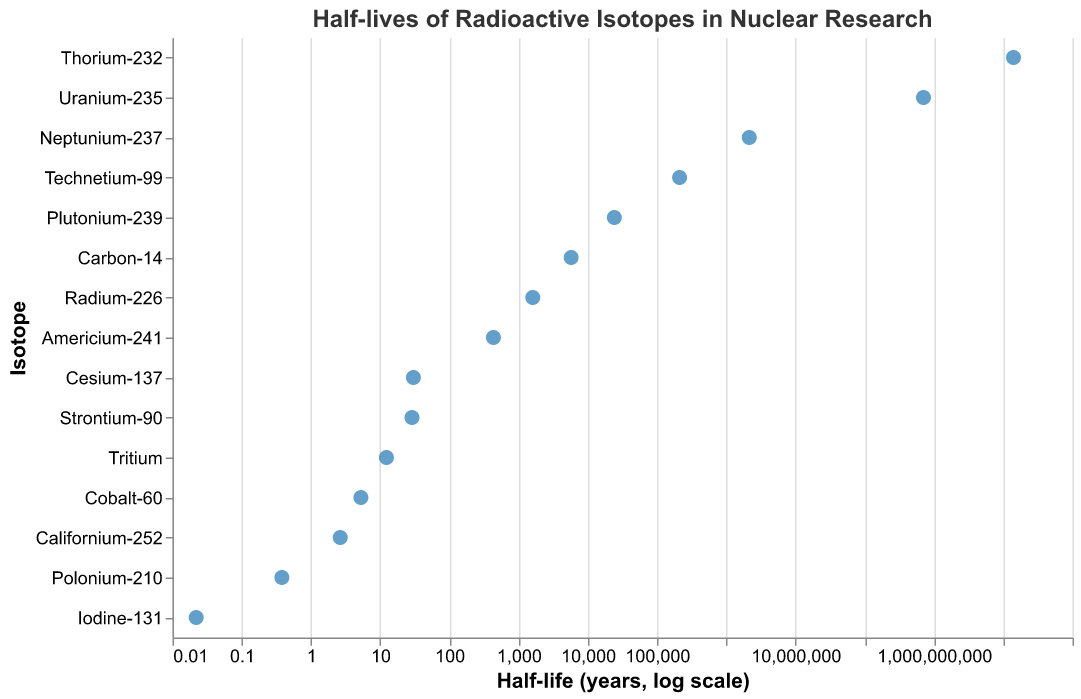What is the title of the plot? The title of the plot is written at the top of the figure for easy identification.
Answer: Half-lives of Radioactive Isotopes in Nuclear Research How many isotopes are represented in the plot? Each isotope is listed on the y-axis, and by counting them, we can determine the number of isotopes. There are 15 isotopes listed.
Answer: 15 Which isotope has the longest half-life? The isotope with the longest half-life will be at the top of the y-axis when sorted in descending order of half-life. Thorium-232 has the longest half-life.
Answer: Thorium-232 Which isotope has the shortest half-life? The isotope with the shortest half-life will be at the bottom of the y-axis when sorted in descending order of half-life. Iodine-131 has the shortest half-life.
Answer: Iodine-131 What is the half-life of Carbon-14? The tooltip or the position on the x-axis corresponding to Carbon-14 will give the half-life. It's labeled on the plot.
Answer: 5730 years Compare the half-lives of Uranium-235 and Plutonium-239. Which one has a longer half-life and by how much? From the plot, identify the half-lives of Uranium-235 and Plutonium-239. Uranium-235's half-life is 703,800,000 years, while Plutonium-239's half-life is 24,100 years. The difference is calculated by subtraction.
Answer: Uranium-235 by 703,775,900 years What is the average half-life of Tritium and Californium-252? Identify the half-lives of Tritium (12.32 years) and Californium-252 (2.65 years) from the plot. Add them together and divide by 2 to get the average. (12.32 + 2.65) / 2 = 7.485 years
Answer: 7.485 years Which isotopes have a half-life less than 10 years? On the logarithmic x-axis, find the isotopes positioned left of the 10-year mark. These include Cobalt-60, Iodine-131, Tritium, Californium-252, and Polonium-210.
Answer: Cobalt-60, Iodine-131, Tritium, Californium-252, Polonium-210 Are there more isotopes with a half-life greater than 1,000 years or less than 1,000 years? Separate the isotopes based on whether their half-lives are greater or less than 1,000 years according to the plot. There are 8 isotopes with half-lives greater than 1,000 years and 7 with less.
Answer: More isotopes have a half-life greater than 1,000 years What is the range of half-lives displayed in the plot? Identify the smallest and largest half-life values from the plot. The smallest is 0.022 years (Iodine-131) and the largest is 14,050,000,000 years (Thorium-232). The range is calculated by subtraction.
Answer: 14,049,999,999.978 years 